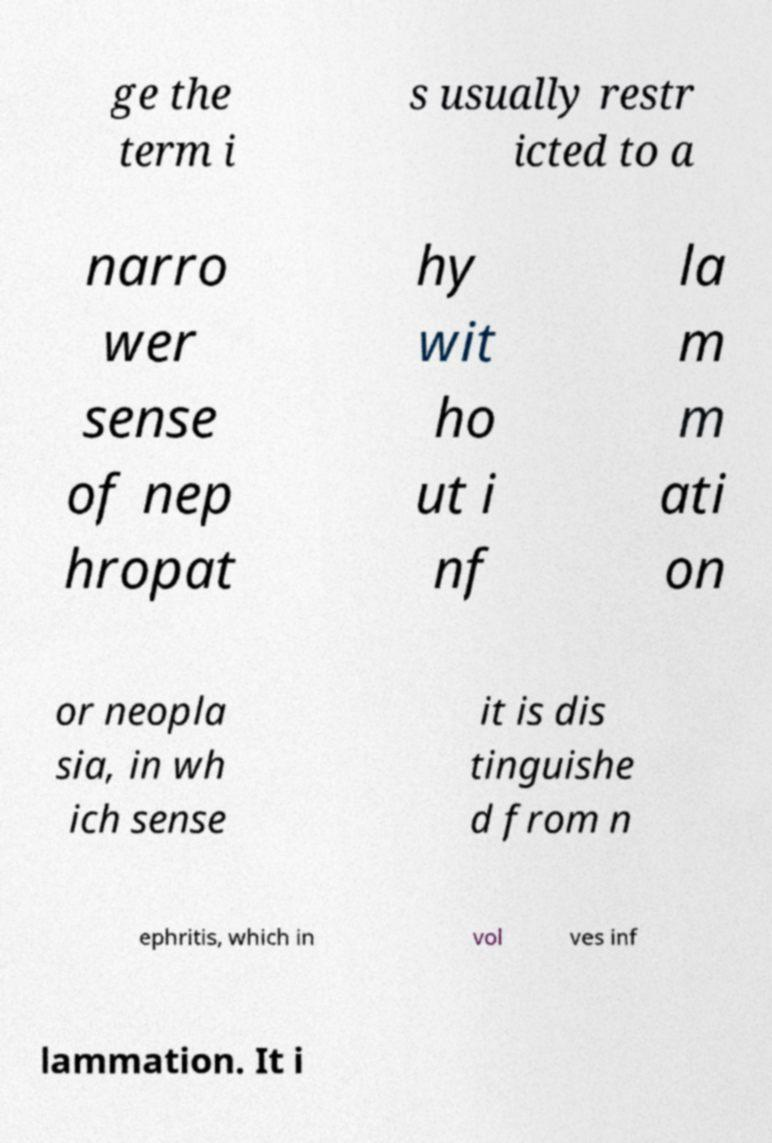Can you read and provide the text displayed in the image?This photo seems to have some interesting text. Can you extract and type it out for me? ge the term i s usually restr icted to a narro wer sense of nep hropat hy wit ho ut i nf la m m ati on or neopla sia, in wh ich sense it is dis tinguishe d from n ephritis, which in vol ves inf lammation. It i 